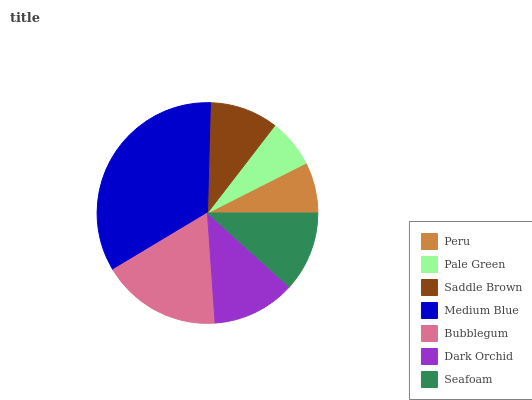Is Pale Green the minimum?
Answer yes or no. Yes. Is Medium Blue the maximum?
Answer yes or no. Yes. Is Saddle Brown the minimum?
Answer yes or no. No. Is Saddle Brown the maximum?
Answer yes or no. No. Is Saddle Brown greater than Pale Green?
Answer yes or no. Yes. Is Pale Green less than Saddle Brown?
Answer yes or no. Yes. Is Pale Green greater than Saddle Brown?
Answer yes or no. No. Is Saddle Brown less than Pale Green?
Answer yes or no. No. Is Seafoam the high median?
Answer yes or no. Yes. Is Seafoam the low median?
Answer yes or no. Yes. Is Saddle Brown the high median?
Answer yes or no. No. Is Saddle Brown the low median?
Answer yes or no. No. 